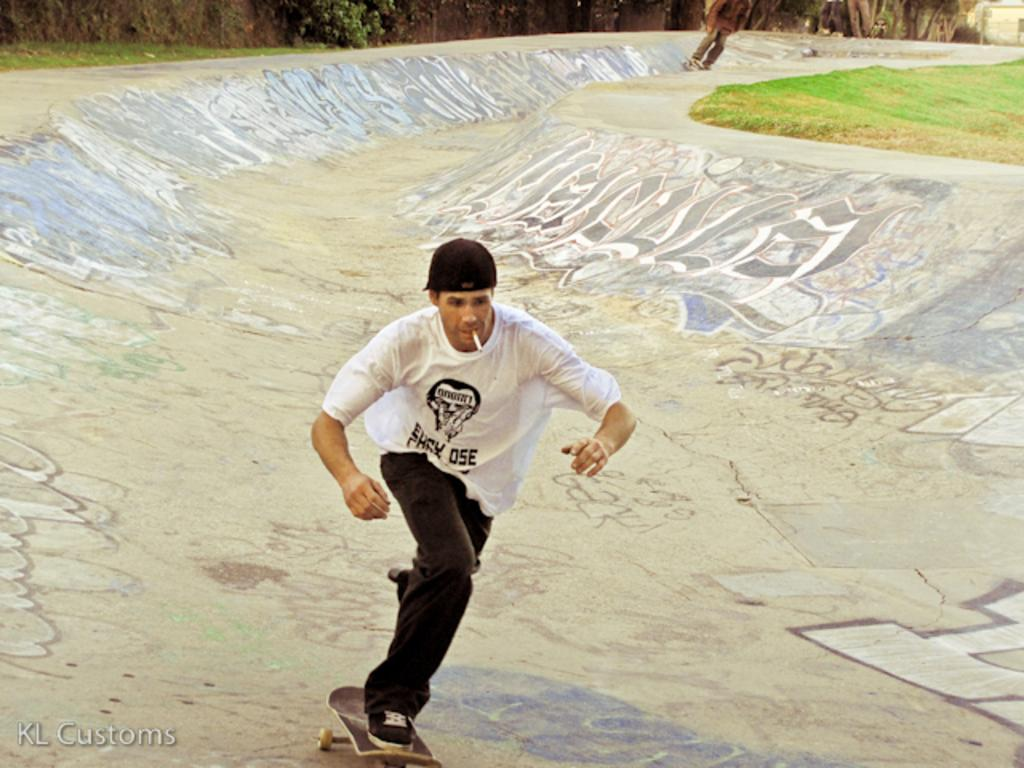What is the person in the image doing? The person is skating on a skateboard in the image. What is the person holding or using while skating? The person has a cigarette in their mouth while skating. What type of terrain is visible in the image? There is grass visible in the image. What other natural elements can be seen in the image? There are trees in the image. How many rabbits are hopping around the person in the image? There are no rabbits present in the image. What answer is the person providing while skating? The image does not show the person providing an answer to any question or statement. 